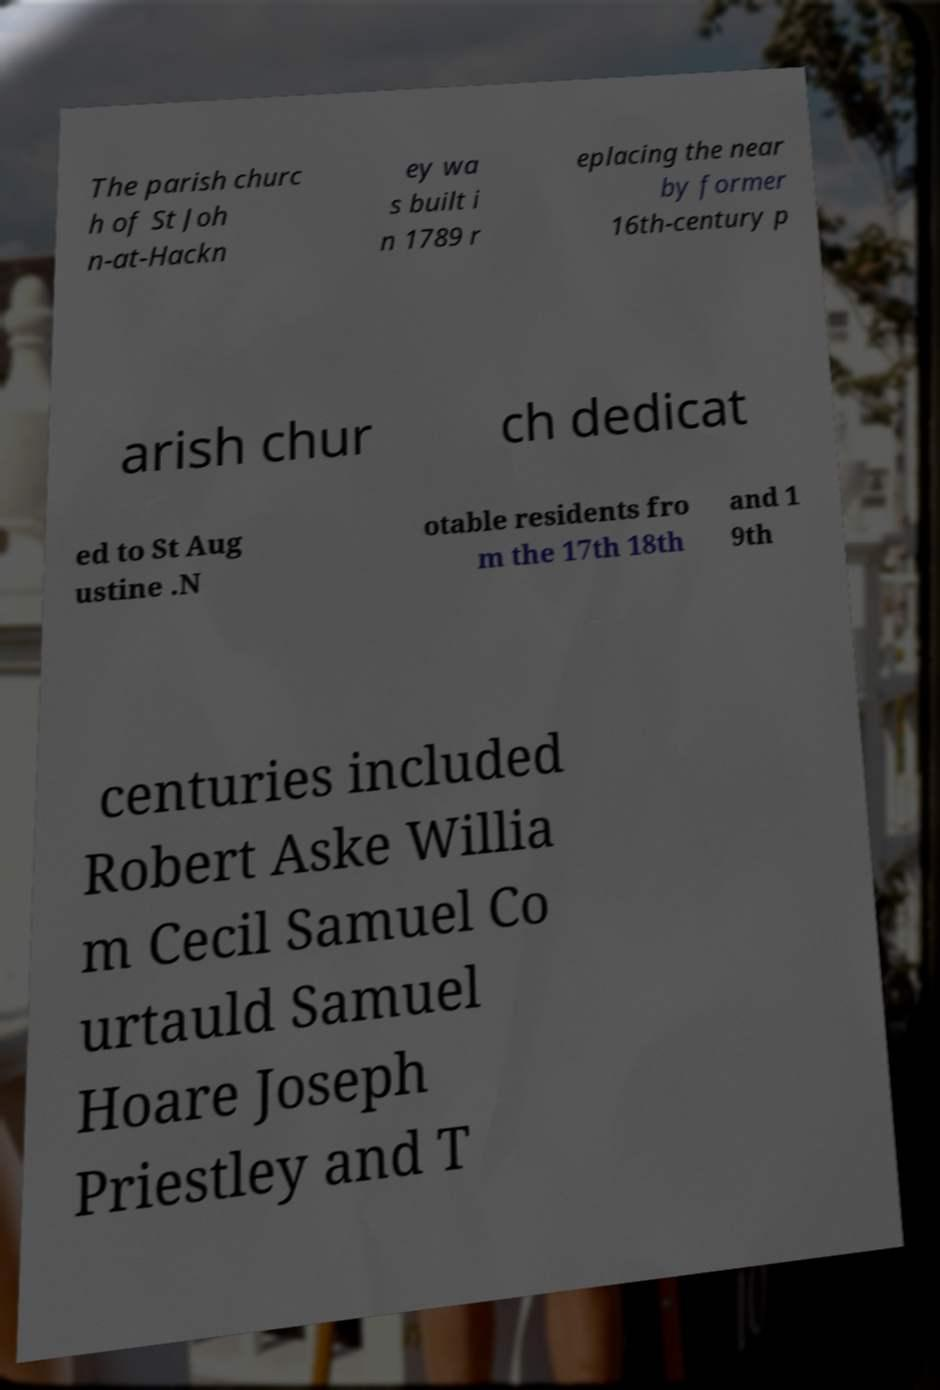Please identify and transcribe the text found in this image. The parish churc h of St Joh n-at-Hackn ey wa s built i n 1789 r eplacing the near by former 16th-century p arish chur ch dedicat ed to St Aug ustine .N otable residents fro m the 17th 18th and 1 9th centuries included Robert Aske Willia m Cecil Samuel Co urtauld Samuel Hoare Joseph Priestley and T 